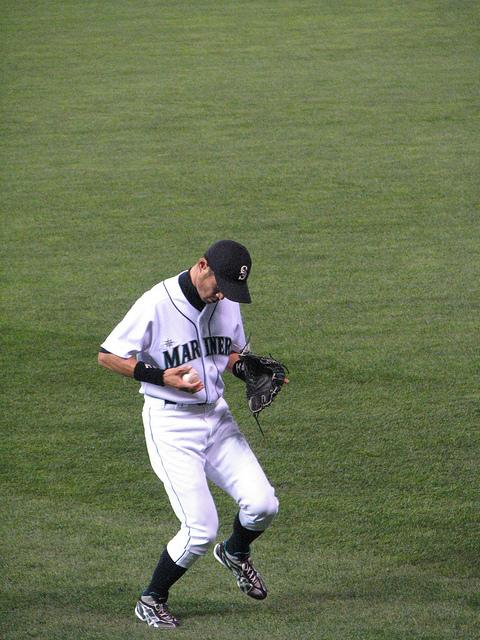Why is the man wearing a glove? Please explain your reasoning. to catch. This is a baseball player. he is on the defensive team. 